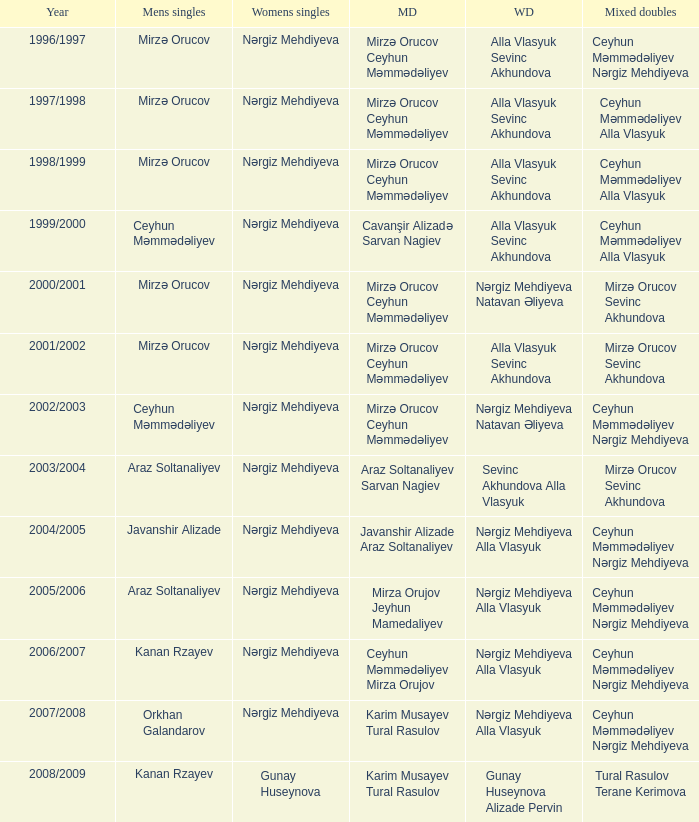Who were all womens doubles for the year 2000/2001? Nərgiz Mehdiyeva Natavan Əliyeva. 